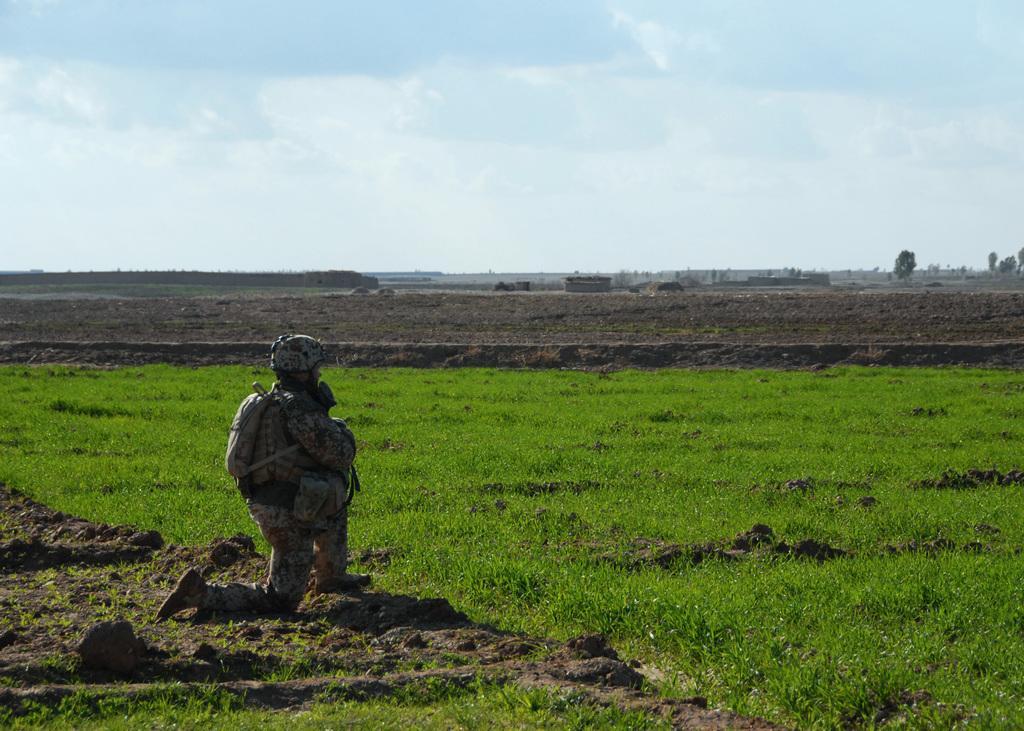In one or two sentences, can you explain what this image depicts? In this image, we can see a person in a squat position is carrying a bag. We can also see the ground with some soil and some green grass. We can also see the sky and some trees. 